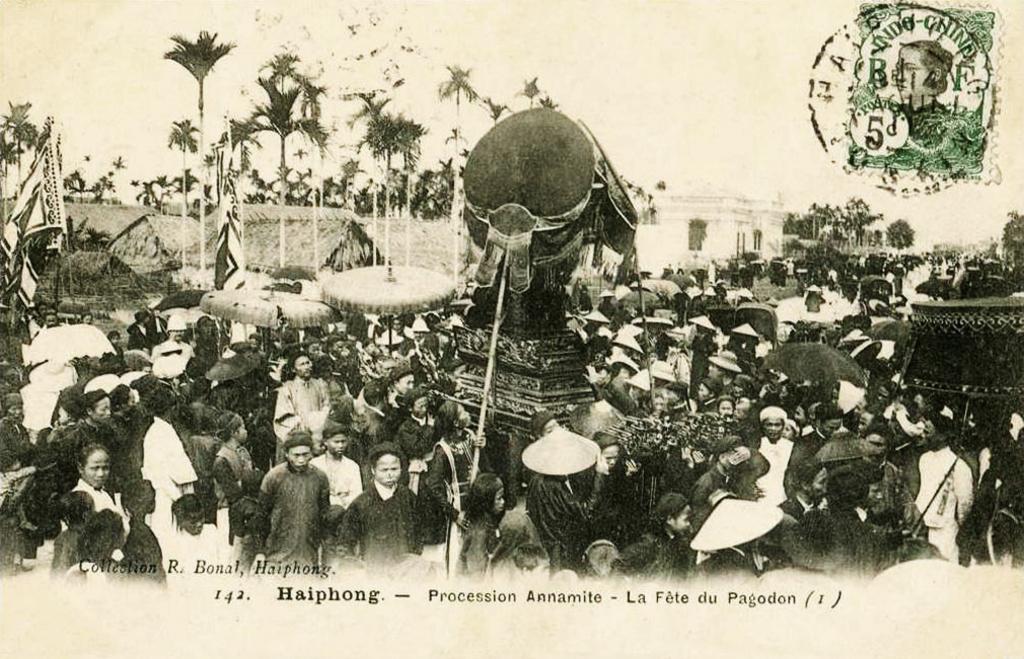Can you describe this image briefly? This is a black and white image and here we can see many people and we can see a statue, flags, poles, trees and buildings and there are umbrellas. 